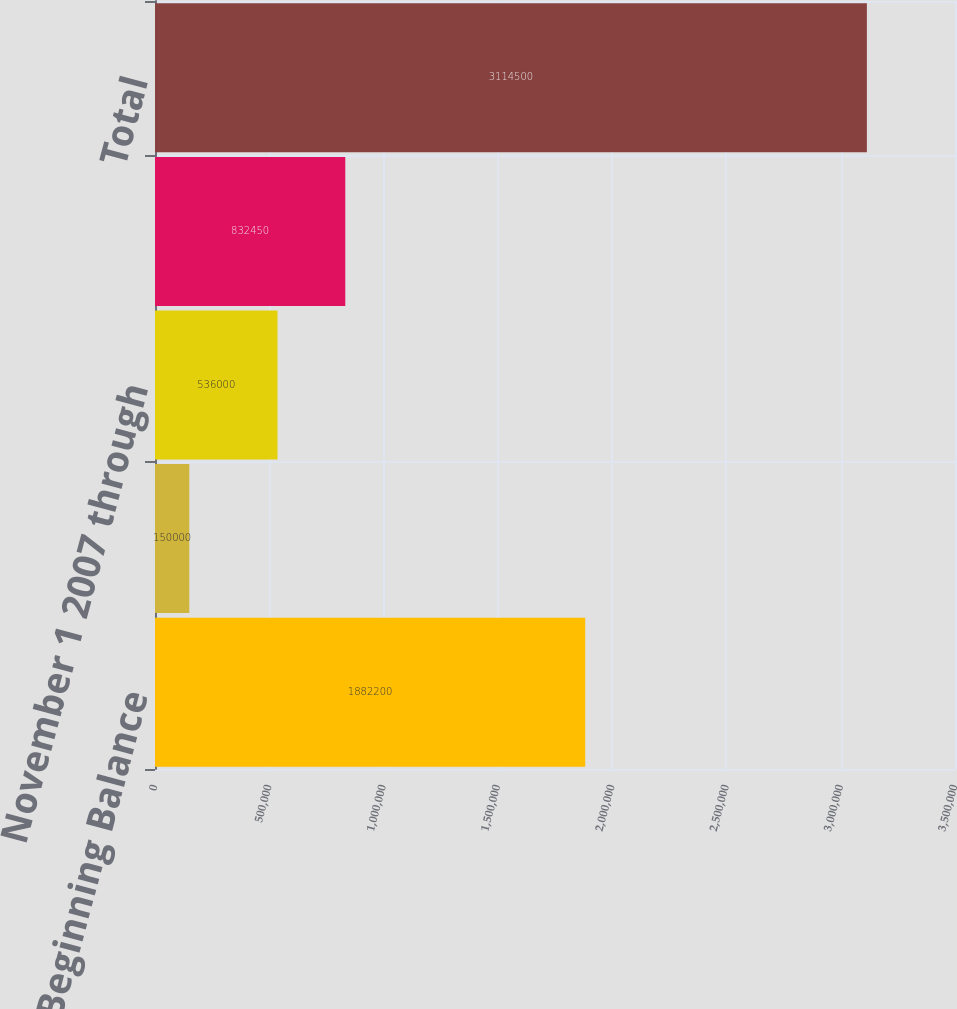Convert chart. <chart><loc_0><loc_0><loc_500><loc_500><bar_chart><fcel>Beginning Balance<fcel>October 1 2007 through October<fcel>November 1 2007 through<fcel>December 1 2007 through<fcel>Total<nl><fcel>1.8822e+06<fcel>150000<fcel>536000<fcel>832450<fcel>3.1145e+06<nl></chart> 